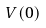<formula> <loc_0><loc_0><loc_500><loc_500>V ( 0 )</formula> 